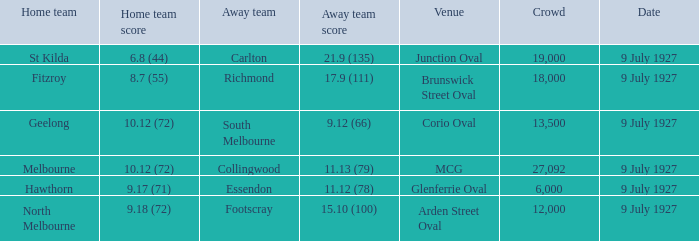What was the largest crowd where the home team was Fitzroy? 18000.0. 